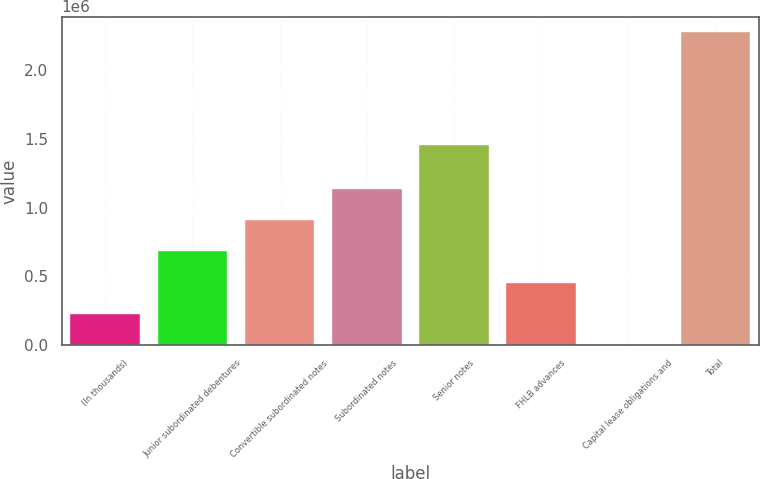Convert chart. <chart><loc_0><loc_0><loc_500><loc_500><bar_chart><fcel>(In thousands)<fcel>Junior subordinated debentures<fcel>Convertible subordinated notes<fcel>Subordinated notes<fcel>Senior notes<fcel>FHLB advances<fcel>Capital lease obligations and<fcel>Total<nl><fcel>227933<fcel>682520<fcel>909813<fcel>1.13711e+06<fcel>1.45478e+06<fcel>455226<fcel>639<fcel>2.27358e+06<nl></chart> 